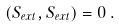Convert formula to latex. <formula><loc_0><loc_0><loc_500><loc_500>( S _ { e x t } , S _ { e x t } ) = 0 \, .</formula> 